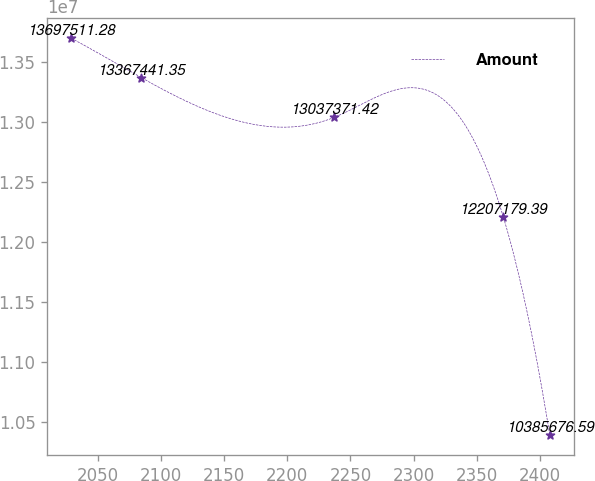Convert chart. <chart><loc_0><loc_0><loc_500><loc_500><line_chart><ecel><fcel>Amount<nl><fcel>2029.02<fcel>1.36975e+07<nl><fcel>2084.63<fcel>1.33674e+07<nl><fcel>2237.14<fcel>1.30374e+07<nl><fcel>2370.93<fcel>1.22072e+07<nl><fcel>2407.73<fcel>1.03857e+07<nl></chart> 